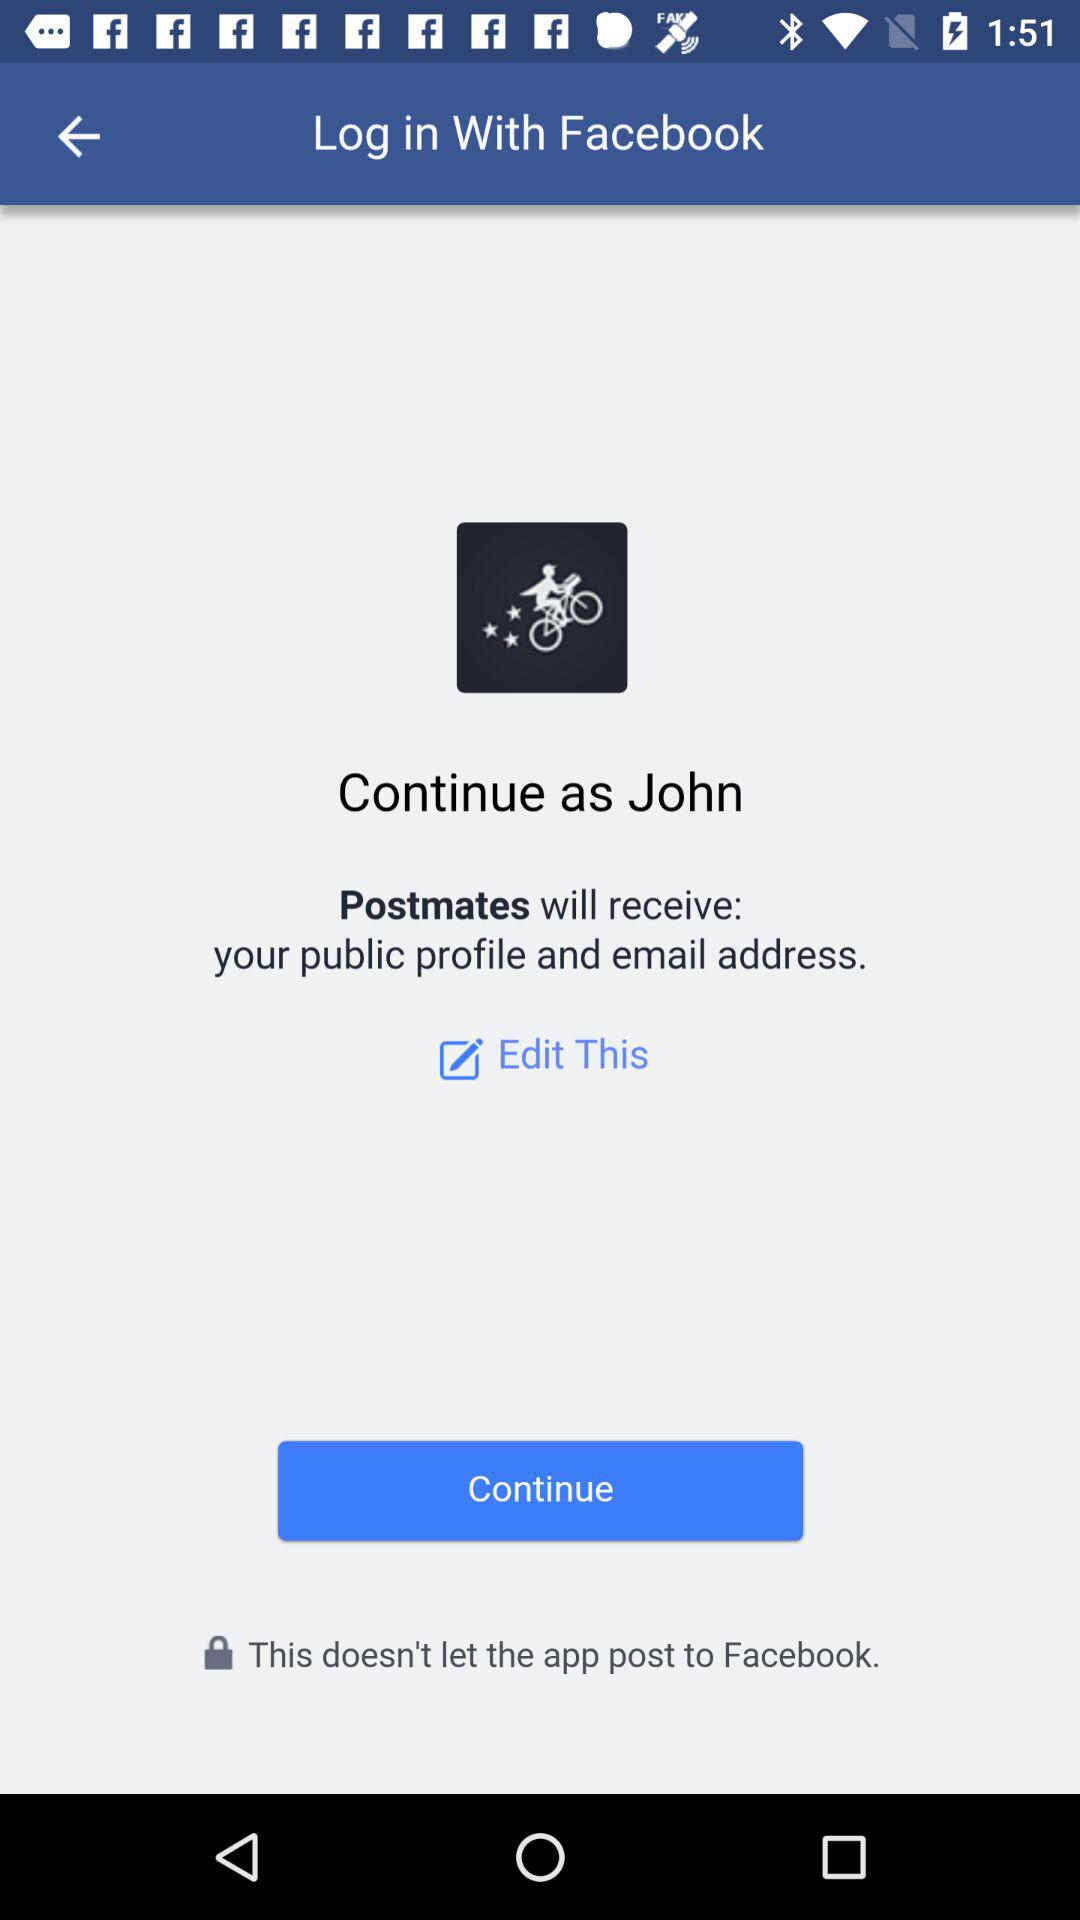Which option is selected?
When the provided information is insufficient, respond with <no answer>. <no answer> 